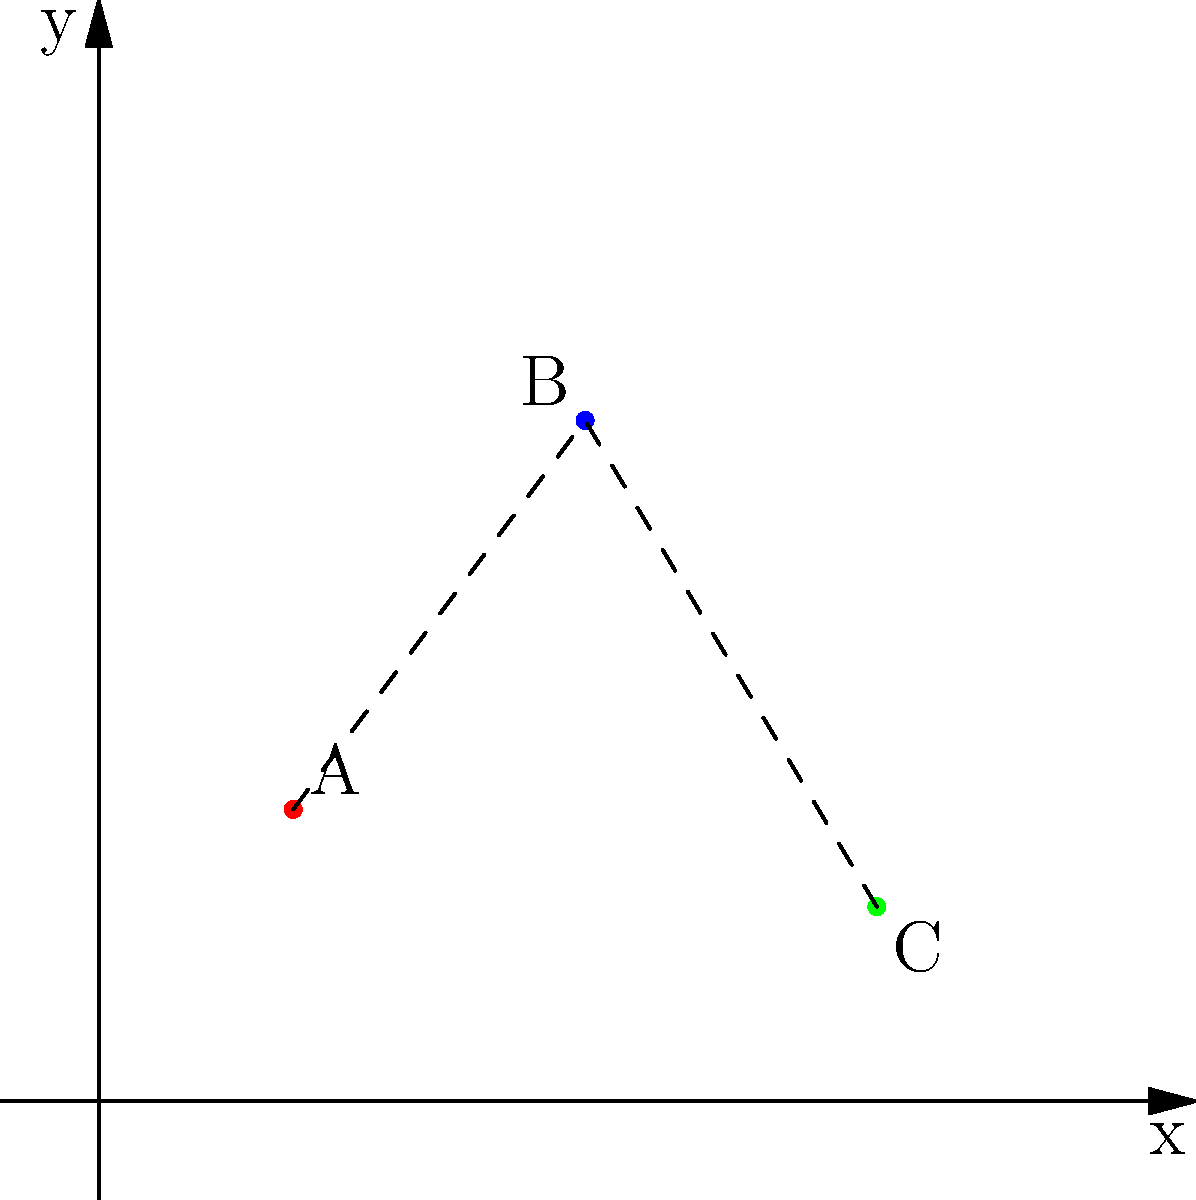In a factory floor layout optimization problem, three pieces of industrial equipment (A, B, and C) are placed on a 2D coordinate grid as shown. Equipment A is at (2,3), B at (5,7), and C at (8,2). What is the total distance of the optimal path connecting all three pieces of equipment, assuming the path must go from A to B to C? To solve this problem, we need to calculate the distances between the equipment and sum them up. We'll use the distance formula between two points: $d = \sqrt{(x_2-x_1)^2 + (y_2-y_1)^2}$

Step 1: Calculate the distance from A to B
$d_{AB} = \sqrt{(5-2)^2 + (7-3)^2} = \sqrt{3^2 + 4^2} = \sqrt{9 + 16} = \sqrt{25} = 5$

Step 2: Calculate the distance from B to C
$d_{BC} = \sqrt{(8-5)^2 + (2-7)^2} = \sqrt{3^2 + (-5)^2} = \sqrt{9 + 25} = \sqrt{34} \approx 5.83$

Step 3: Sum up the distances
Total distance = $d_{AB} + d_{BC} = 5 + 5.83 = 10.83$

Therefore, the total distance of the optimal path connecting all three pieces of equipment is approximately 10.83 units.
Answer: 10.83 units 